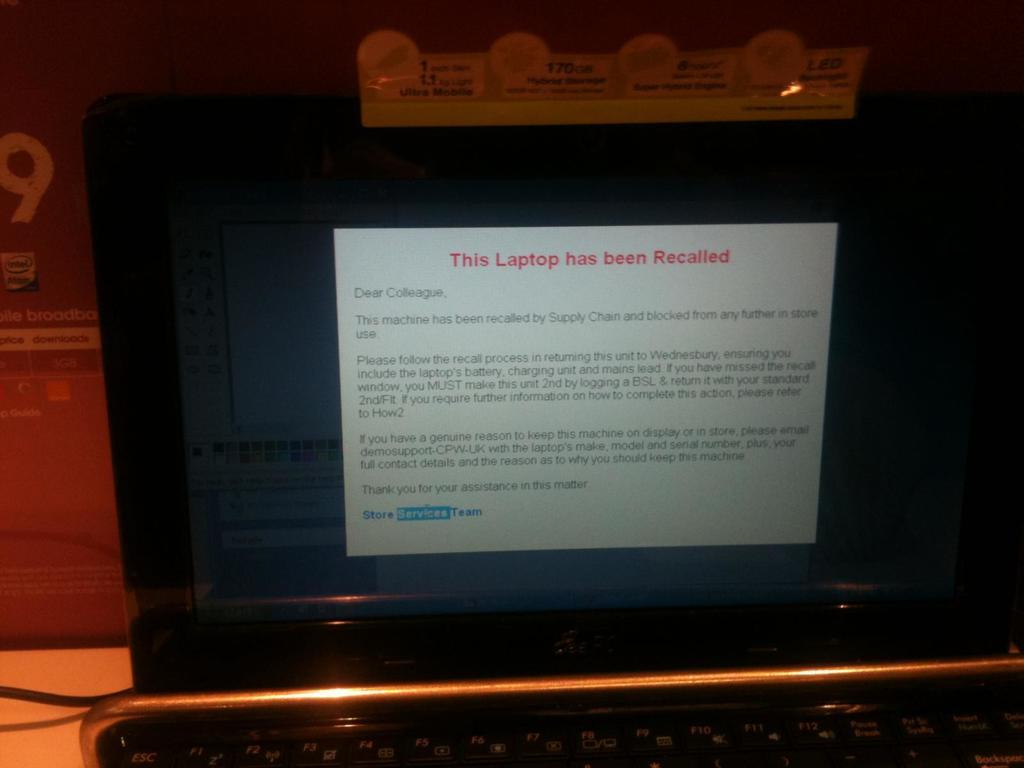<image>
Provide a brief description of the given image. An open black laptop with the words This Laptop has been Recalled on the screen. 